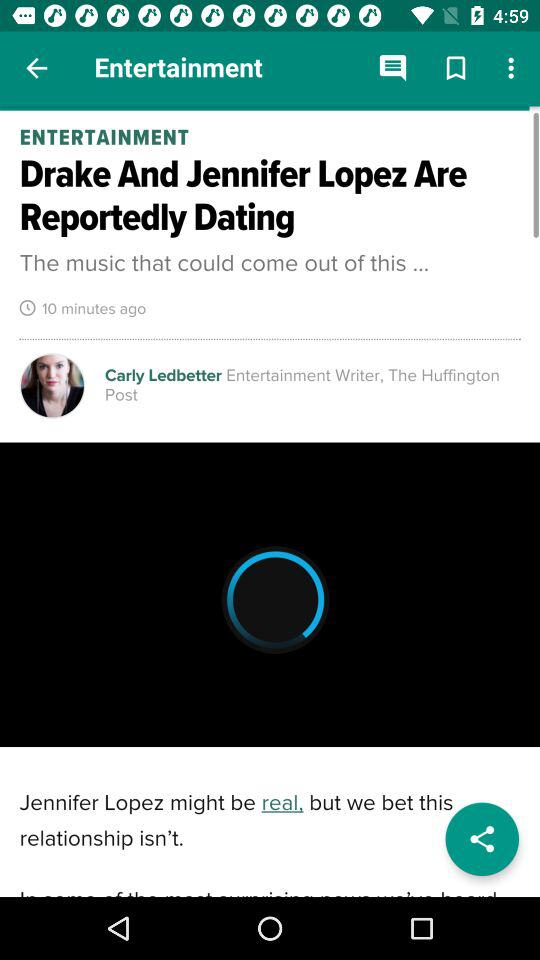What's the title of the post? The title of the post is "Drake And Jennifer Lopez Are Reportedly Dating". 